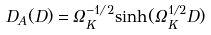Convert formula to latex. <formula><loc_0><loc_0><loc_500><loc_500>D _ { A } ( D ) = \Omega _ { K } ^ { - 1 / 2 } { \sinh ( \Omega _ { K } ^ { 1 / 2 } D ) }</formula> 